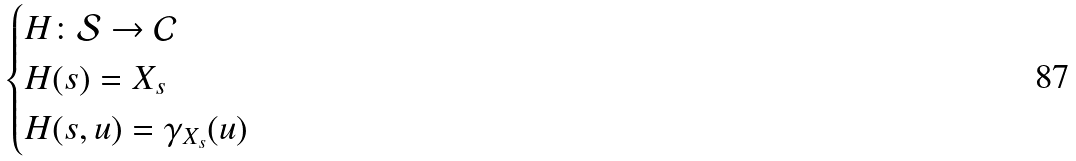Convert formula to latex. <formula><loc_0><loc_0><loc_500><loc_500>\begin{cases} H \colon \mathcal { S } \rightarrow \mathcal { C } \\ H ( s ) = X _ { s } \\ H ( s , u ) = \gamma _ { X _ { s } } ( u ) \end{cases}</formula> 